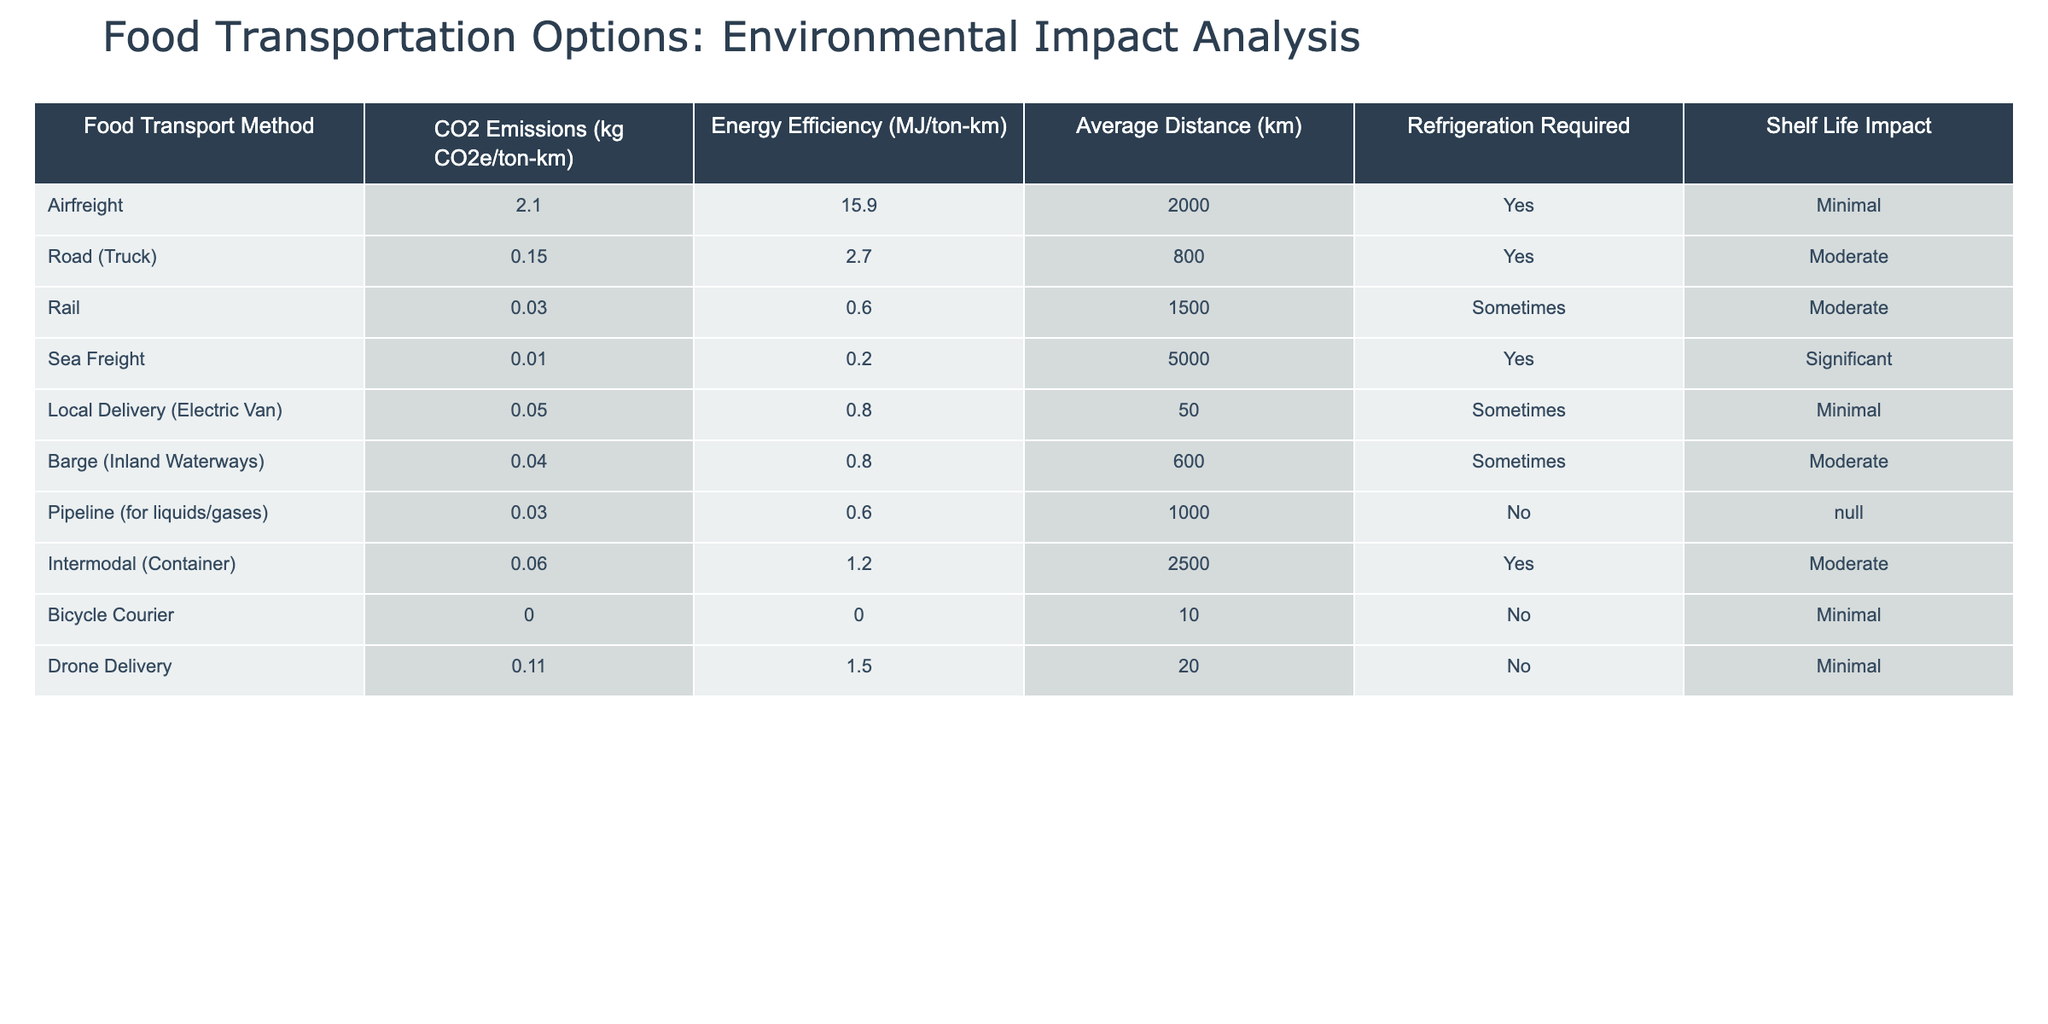What are the CO2 emissions for road transport? The table lists the CO2 emissions for road (truck) transport as 0.15 kg CO2e/ton-km.
Answer: 0.15 kg CO2e/ton-km Which food transport method has the highest energy efficiency? The method with the highest energy efficiency is airfreight, which shows an energy efficiency of 15.9 MJ/ton-km.
Answer: Airfreight How many food transport methods require refrigeration? By examining the table, the methods that require refrigeration are airfreight, road (truck), sea freight, and intermodal (container), totaling four methods.
Answer: 4 What is the average distance for sea freight and airfreight combined? The distances for sea freight and airfreight are 5000 km and 2000 km respectively. Summing them gives 5000 + 2000 = 7000 km. Dividing by 2 for the average gives 7000/2 = 3500 km.
Answer: 3500 km Is there a food transport method that does not require refrigeration and has minimal shelf life impact? The food transport method that fits this criterion is the bicycle courier, which requires no refrigeration and has a minimal shelf life impact.
Answer: Yes Which transport method has the lowest CO2 emissions? The table indicates that sea freight has the lowest CO2 emissions at 0.01 kg CO2e/ton-km.
Answer: Sea freight What is the total CO2 emissions from local delivery (electric van) and pipeline for liquids/gases? The local delivery (electric van) has CO2 emissions of 0.05 kg CO2e/ton-km, and pipeline for liquids/gases has 0.03 kg CO2e/ton-km. Adding these results in 0.05 + 0.03 = 0.08 kg CO2e/ton-km.
Answer: 0.08 kg CO2e/ton-km Which method has a significant shelf life impact and requires refrigeration? The only method that has a significant shelf life impact and also requires refrigeration is sea freight.
Answer: Sea freight How does the energy efficiency of rail compare to bicycle courier? From the table, rail has an energy efficiency of 0.6 MJ/ton-km, while the bicycle courier has 0 MJ/ton-km. The bicycle courier's efficiency exceeds that of rail, as it uses no energy for the delivery.
Answer: Bicycle courier has higher efficiency 